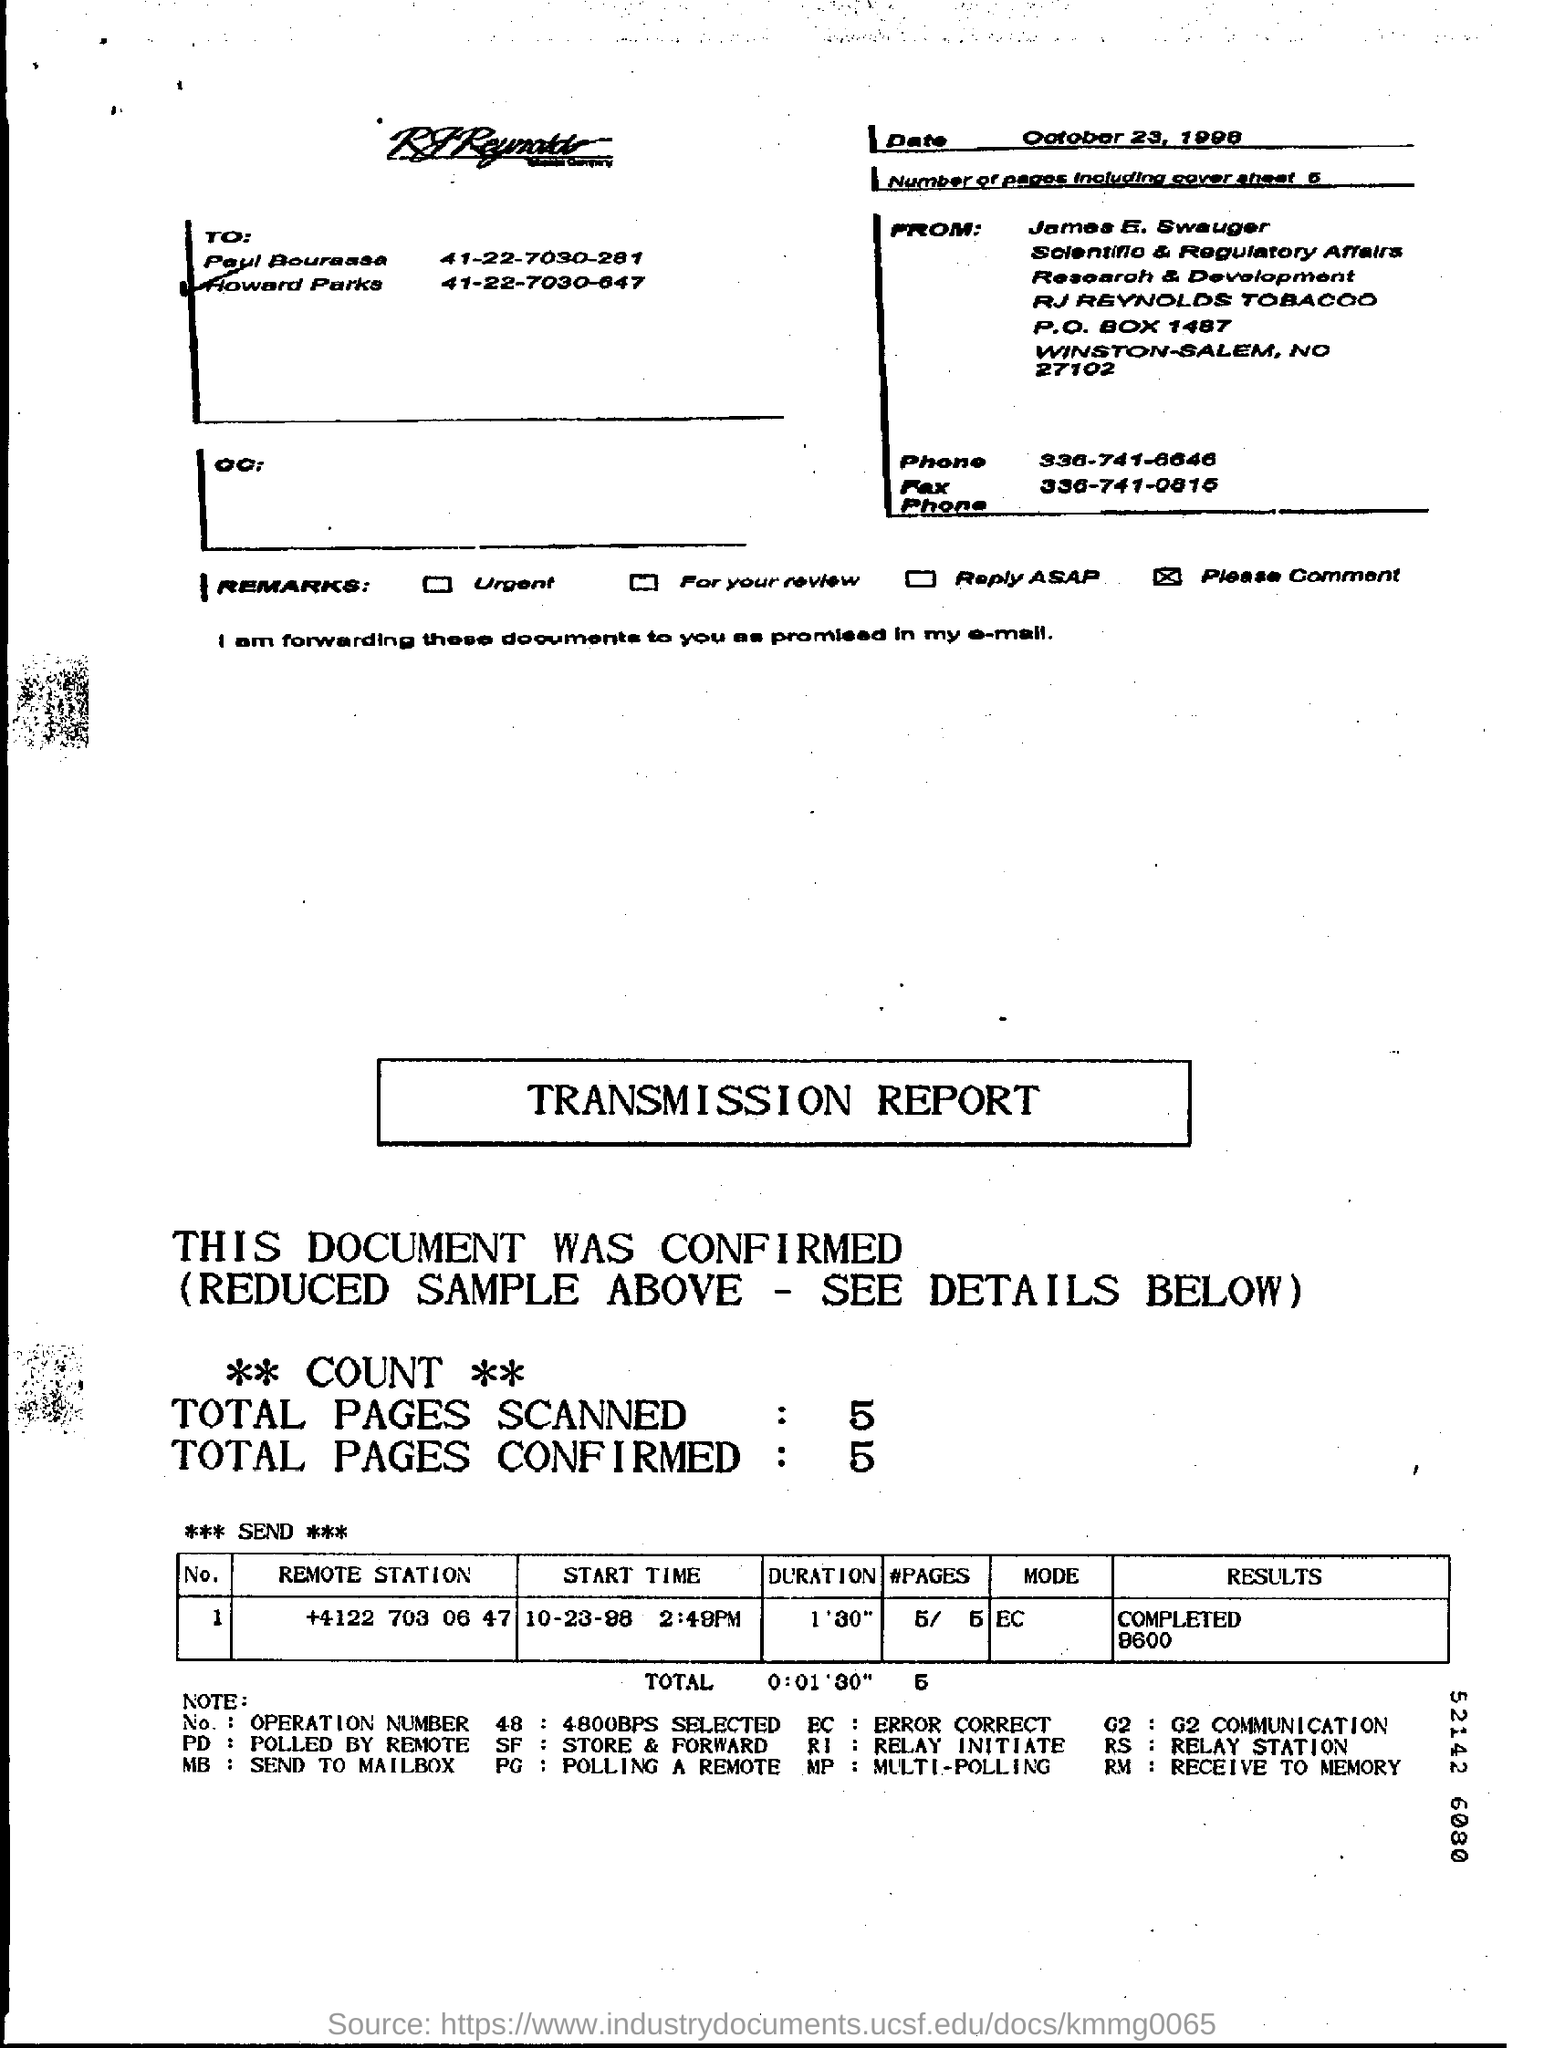On which date, the fax is sent?
Provide a short and direct response. October 23, 1998. Who is the sender of the Fax?
Make the answer very short. James E. Swauger. What is the Fax Phone No of James E. Swauger?
Provide a succinct answer. 336-741-0815. How many pages are there in the fax including cover sheet?
Offer a very short reply. 5. What is the Total duration mentioned in the transmission report?
Your answer should be compact. 0:01'30". 